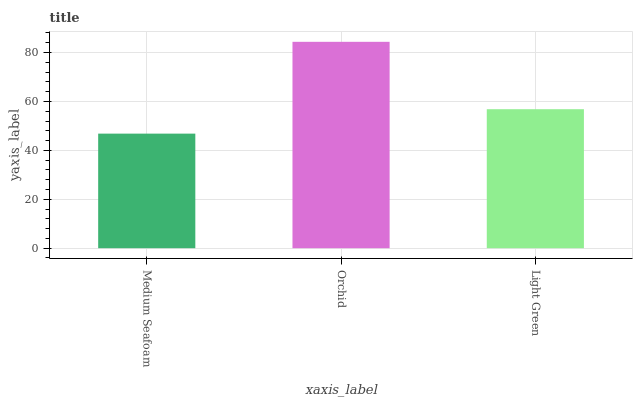Is Light Green the minimum?
Answer yes or no. No. Is Light Green the maximum?
Answer yes or no. No. Is Orchid greater than Light Green?
Answer yes or no. Yes. Is Light Green less than Orchid?
Answer yes or no. Yes. Is Light Green greater than Orchid?
Answer yes or no. No. Is Orchid less than Light Green?
Answer yes or no. No. Is Light Green the high median?
Answer yes or no. Yes. Is Light Green the low median?
Answer yes or no. Yes. Is Orchid the high median?
Answer yes or no. No. Is Orchid the low median?
Answer yes or no. No. 